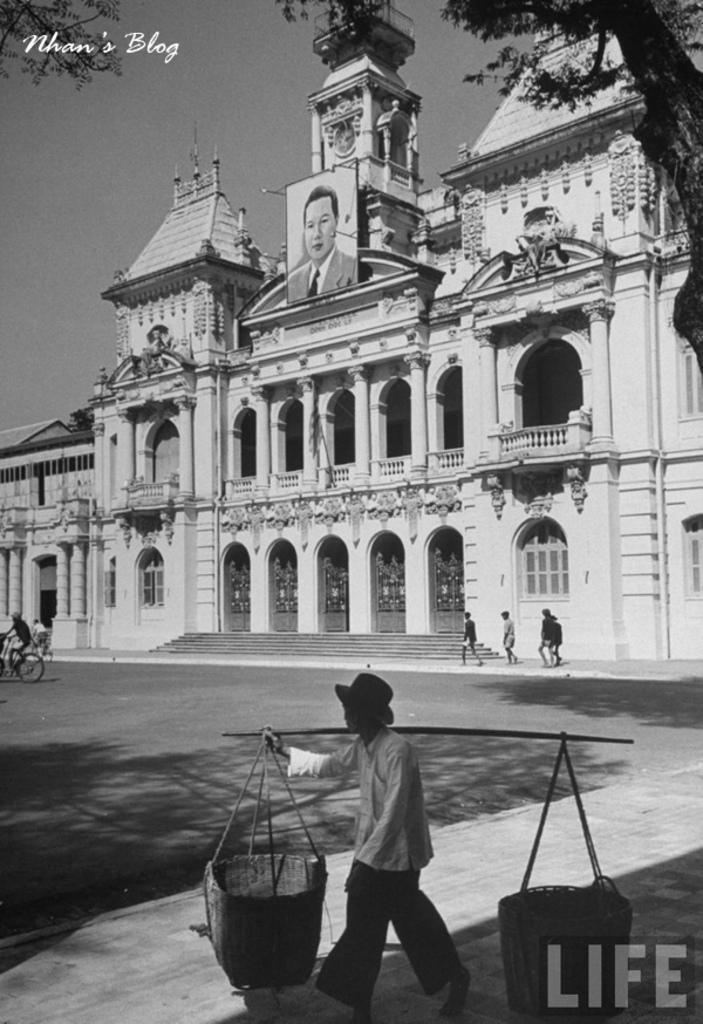Please provide a concise description of this image. In this image I can see the person walking and holding the carrying pole. In the background I can see few persons walking and I can also see the person riding the bi-cycle and I can also see the building and few trees and the image is in black and white. 